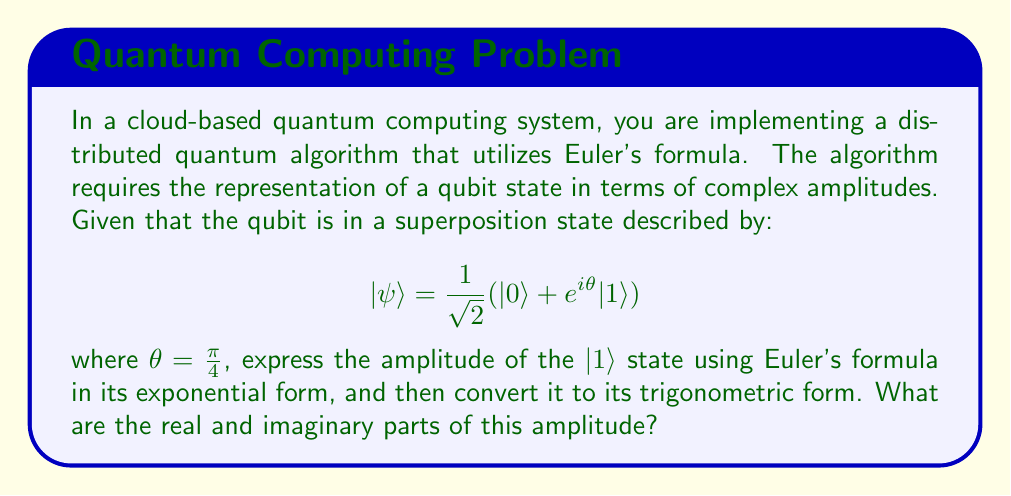Help me with this question. To solve this problem, we'll follow these steps:

1) First, recall Euler's formula:
   $$ e^{ix} = \cos(x) + i\sin(x) $$

2) In our case, $\theta = \frac{\pi}{4}$, so the amplitude of the $|1\rangle$ state is:
   $$ \frac{1}{\sqrt{2}}e^{i\frac{\pi}{4}} $$

3) Applying Euler's formula:
   $$ \frac{1}{\sqrt{2}}e^{i\frac{\pi}{4}} = \frac{1}{\sqrt{2}}(\cos(\frac{\pi}{4}) + i\sin(\frac{\pi}{4})) $$

4) We know that:
   $$ \cos(\frac{\pi}{4}) = \sin(\frac{\pi}{4}) = \frac{1}{\sqrt{2}} $$

5) Substituting these values:
   $$ \frac{1}{\sqrt{2}}(\cos(\frac{\pi}{4}) + i\sin(\frac{\pi}{4})) = \frac{1}{\sqrt{2}}(\frac{1}{\sqrt{2}} + i\frac{1}{\sqrt{2}}) $$

6) Simplifying:
   $$ \frac{1}{\sqrt{2}}(\frac{1}{\sqrt{2}} + i\frac{1}{\sqrt{2}}) = \frac{1}{2} + i\frac{1}{2} $$

Therefore, the real part of the amplitude is $\frac{1}{2}$ and the imaginary part is $\frac{1}{2}$.
Answer: Real part: $\frac{1}{2}$
Imaginary part: $\frac{1}{2}$ 